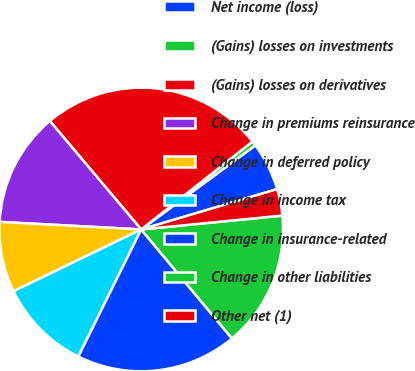Convert chart. <chart><loc_0><loc_0><loc_500><loc_500><pie_chart><fcel>Net income (loss)<fcel>(Gains) losses on investments<fcel>(Gains) losses on derivatives<fcel>Change in premiums reinsurance<fcel>Change in deferred policy<fcel>Change in income tax<fcel>Change in insurance-related<fcel>Change in other liabilities<fcel>Other net (1)<nl><fcel>5.52%<fcel>0.53%<fcel>25.5%<fcel>13.01%<fcel>8.02%<fcel>10.52%<fcel>18.36%<fcel>15.51%<fcel>3.03%<nl></chart> 